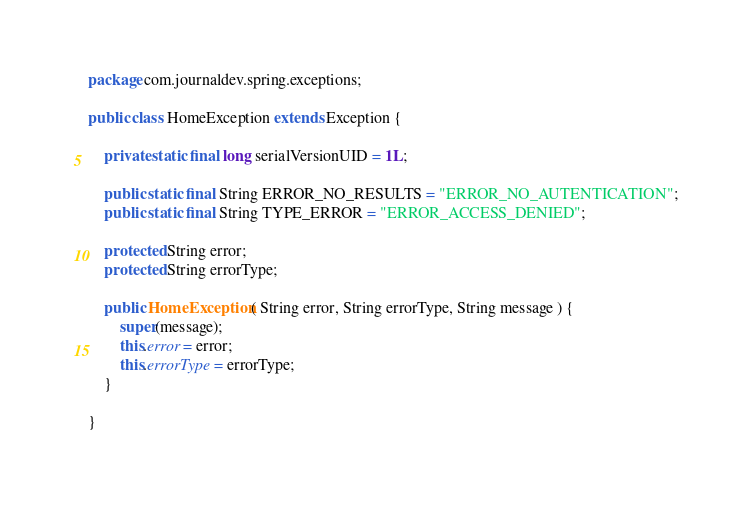<code> <loc_0><loc_0><loc_500><loc_500><_Java_>package com.journaldev.spring.exceptions;

public class HomeException extends Exception {

	private static final long serialVersionUID = 1L;
	
	public static final String ERROR_NO_RESULTS = "ERROR_NO_AUTENTICATION";
	public static final String TYPE_ERROR = "ERROR_ACCESS_DENIED";

	protected String error;
	protected String errorType;
	
	public HomeException( String error, String errorType, String message ) {
		super(message);
		this.error = error;
		this.errorType = errorType;
	}
	
}
</code> 